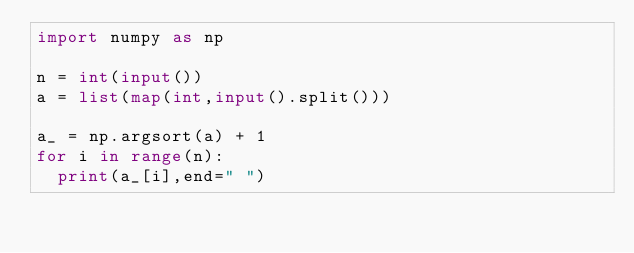Convert code to text. <code><loc_0><loc_0><loc_500><loc_500><_Python_>import numpy as np

n = int(input())
a = list(map(int,input().split()))

a_ = np.argsort(a) + 1
for i in range(n):
  print(a_[i],end=" ")</code> 